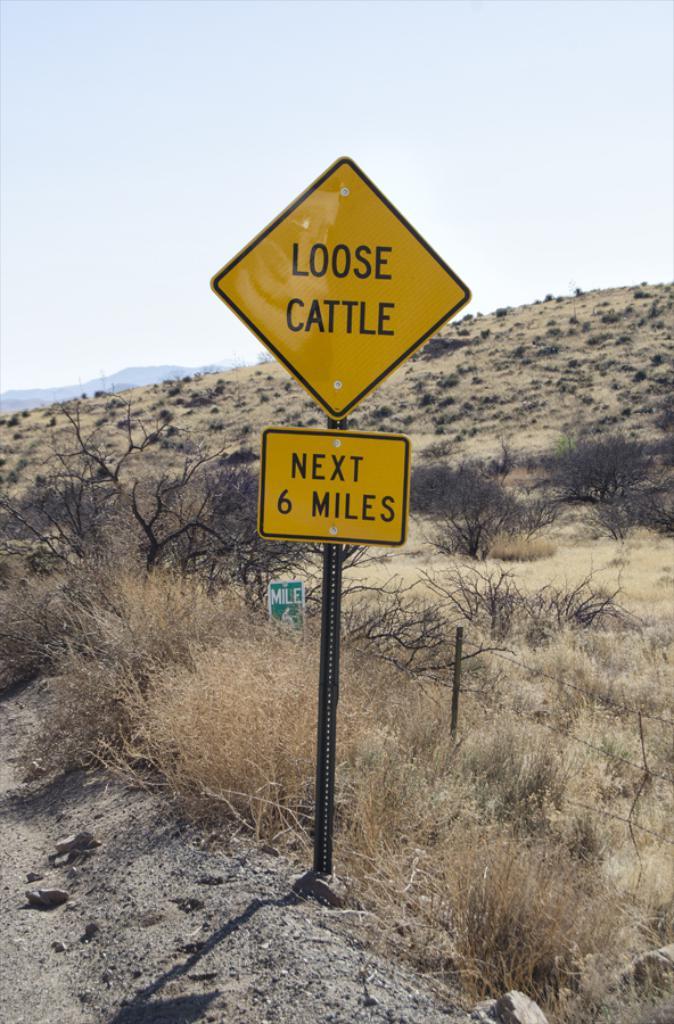What is the sign warning for?
Make the answer very short. Loose cattle. 